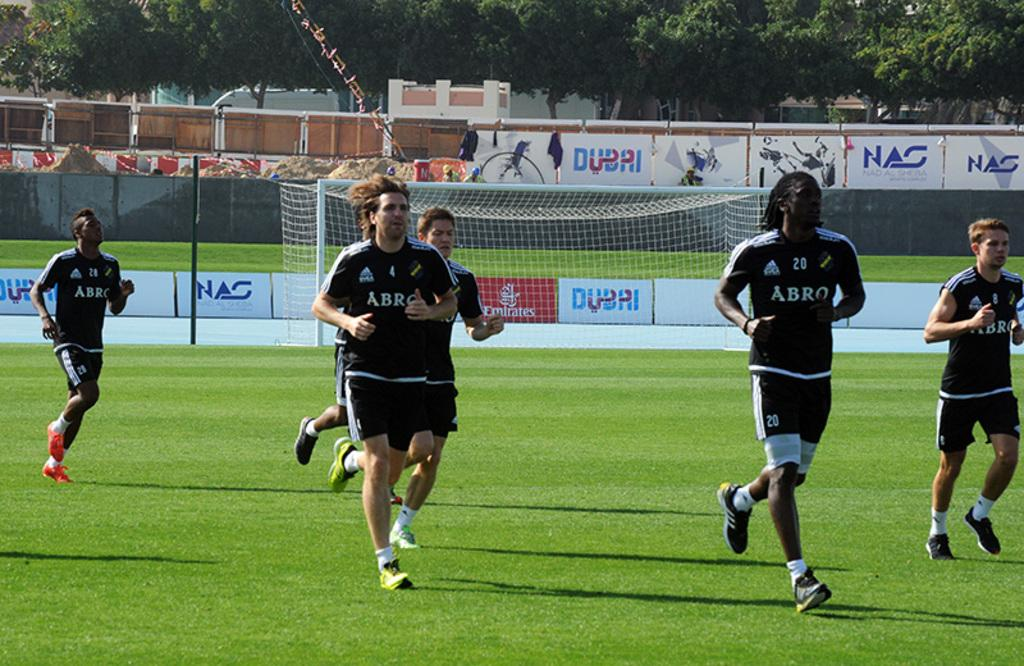<image>
Give a short and clear explanation of the subsequent image. Men in soccer shirts that say Abro are running for practice. 